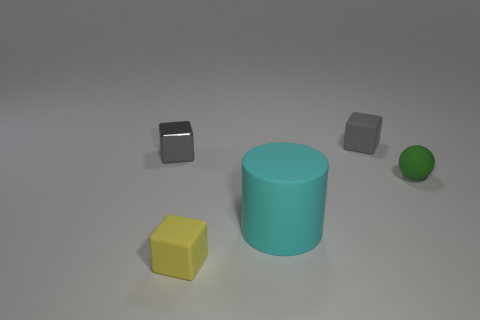How many things are to the right of the gray shiny object and behind the cyan cylinder?
Ensure brevity in your answer.  2. There is a tiny matte cube that is to the right of the rubber cylinder; does it have the same color as the block to the left of the tiny yellow object?
Your response must be concise. Yes. Is there any other thing that is the same material as the yellow block?
Provide a short and direct response. Yes. There is a green matte thing; are there any cyan things on the right side of it?
Your answer should be very brief. No. Are there an equal number of tiny rubber balls on the right side of the tiny green sphere and large matte things?
Offer a terse response. No. Are there any small things that are behind the small gray object that is left of the tiny matte thing behind the tiny ball?
Offer a terse response. Yes. What is the large cylinder made of?
Offer a terse response. Rubber. How many other things are the same shape as the small metallic object?
Offer a terse response. 2. Do the small gray metallic thing and the small gray rubber object have the same shape?
Provide a succinct answer. Yes. What number of things are gray cubes that are on the left side of the cyan matte thing or rubber objects that are behind the big cyan thing?
Offer a terse response. 3. 